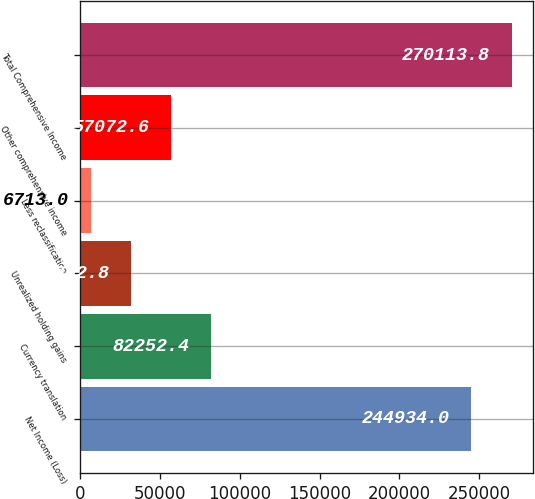Convert chart. <chart><loc_0><loc_0><loc_500><loc_500><bar_chart><fcel>Net Income (Loss)<fcel>Currency translation<fcel>Unrealized holding gains<fcel>Less reclassification<fcel>Other comprehensive income<fcel>Total Comprehensive Income<nl><fcel>244934<fcel>82252.4<fcel>31892.8<fcel>6713<fcel>57072.6<fcel>270114<nl></chart> 